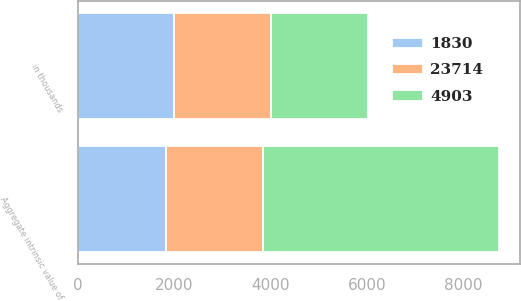Convert chart. <chart><loc_0><loc_0><loc_500><loc_500><stacked_bar_chart><ecel><fcel>in thousands<fcel>Aggregate intrinsic value of<nl><fcel>1830<fcel>2010<fcel>1830<nl><fcel>4903<fcel>2009<fcel>4903<nl><fcel>23714<fcel>2008<fcel>2009<nl></chart> 